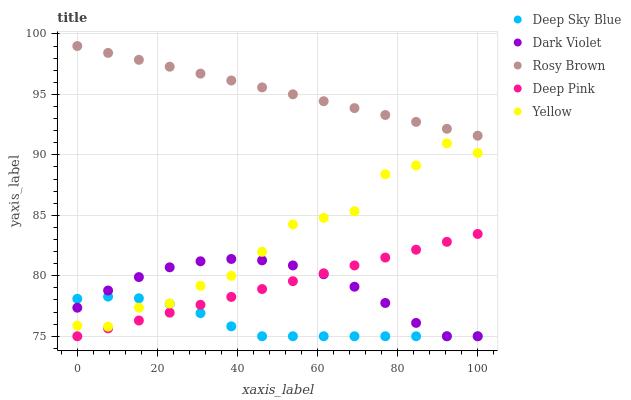Does Deep Sky Blue have the minimum area under the curve?
Answer yes or no. Yes. Does Rosy Brown have the maximum area under the curve?
Answer yes or no. Yes. Does Yellow have the minimum area under the curve?
Answer yes or no. No. Does Yellow have the maximum area under the curve?
Answer yes or no. No. Is Rosy Brown the smoothest?
Answer yes or no. Yes. Is Yellow the roughest?
Answer yes or no. Yes. Is Dark Violet the smoothest?
Answer yes or no. No. Is Dark Violet the roughest?
Answer yes or no. No. Does Dark Violet have the lowest value?
Answer yes or no. Yes. Does Yellow have the lowest value?
Answer yes or no. No. Does Rosy Brown have the highest value?
Answer yes or no. Yes. Does Yellow have the highest value?
Answer yes or no. No. Is Deep Pink less than Rosy Brown?
Answer yes or no. Yes. Is Yellow greater than Deep Pink?
Answer yes or no. Yes. Does Deep Pink intersect Deep Sky Blue?
Answer yes or no. Yes. Is Deep Pink less than Deep Sky Blue?
Answer yes or no. No. Is Deep Pink greater than Deep Sky Blue?
Answer yes or no. No. Does Deep Pink intersect Rosy Brown?
Answer yes or no. No. 